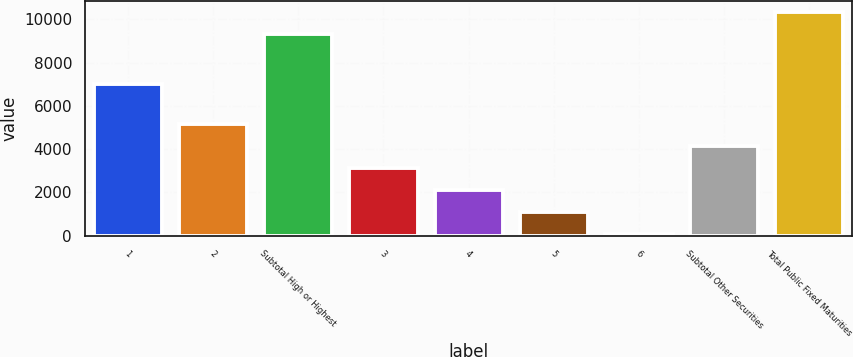Convert chart. <chart><loc_0><loc_0><loc_500><loc_500><bar_chart><fcel>1<fcel>2<fcel>Subtotal High or Highest<fcel>3<fcel>4<fcel>5<fcel>6<fcel>Subtotal Other Securities<fcel>Total Public Fixed Maturities<nl><fcel>6986<fcel>5137<fcel>9335<fcel>3112.6<fcel>2100.4<fcel>1088.2<fcel>76<fcel>4124.8<fcel>10347.2<nl></chart> 